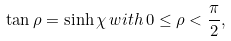<formula> <loc_0><loc_0><loc_500><loc_500>\tan \rho = \sinh \chi \, w i t h \, 0 \leq \rho < \frac { \pi } { 2 } ,</formula> 